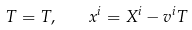<formula> <loc_0><loc_0><loc_500><loc_500>T = T , \quad x ^ { i } = X ^ { i } - v ^ { i } T</formula> 